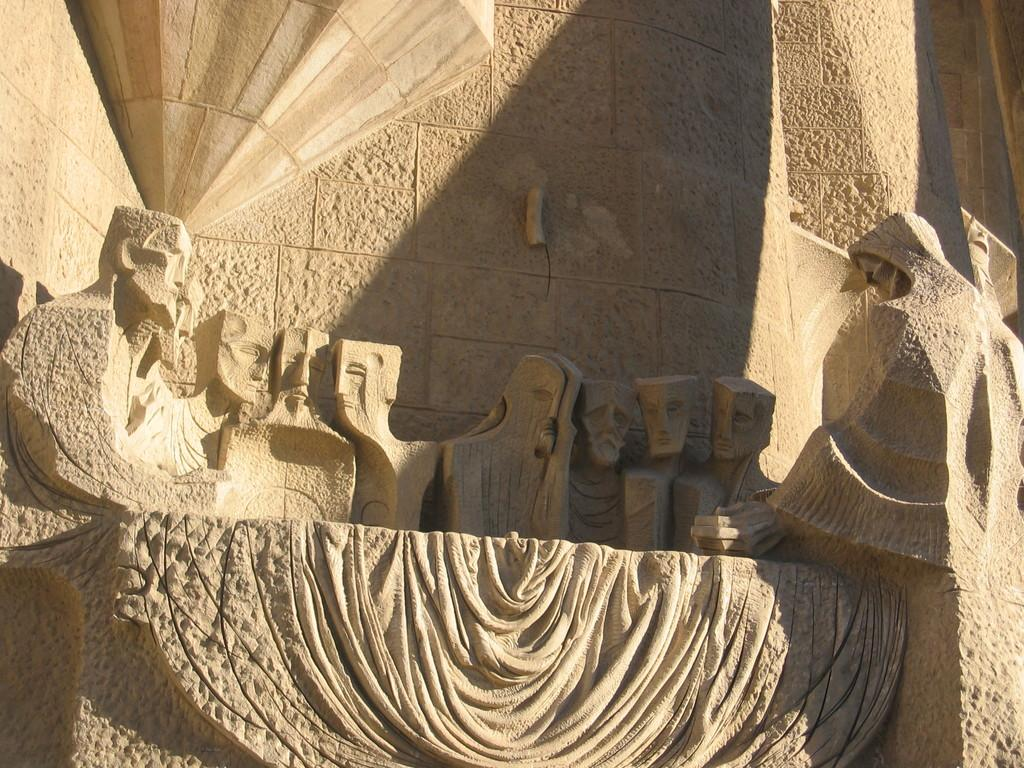What type of art is present in the image? There are sculptures in the image. What else can be seen in the image besides the sculptures? There is a wall in the image. What type of honey is being used to create the sculptures in the image? There is no honey present in the image; the sculptures are not made of honey. 